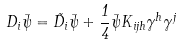<formula> <loc_0><loc_0><loc_500><loc_500>D _ { i } \/ \bar { \psi } = \tilde { D } _ { i } \/ \bar { \psi } + \frac { 1 } { 4 } \bar { \psi } K _ { i j h } \gamma ^ { h } \gamma ^ { j }</formula> 